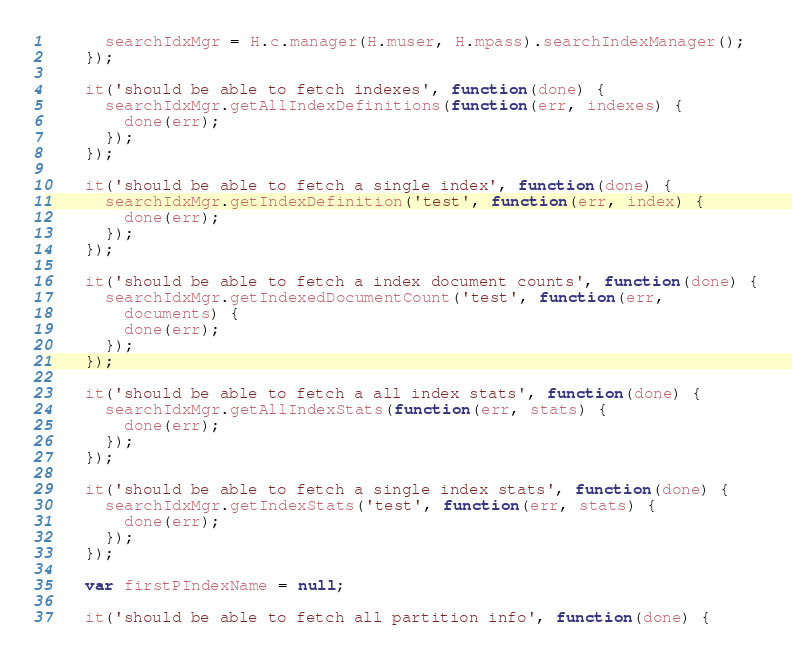<code> <loc_0><loc_0><loc_500><loc_500><_JavaScript_>      searchIdxMgr = H.c.manager(H.muser, H.mpass).searchIndexManager();
    });

    it('should be able to fetch indexes', function(done) {
      searchIdxMgr.getAllIndexDefinitions(function(err, indexes) {
        done(err);
      });
    });

    it('should be able to fetch a single index', function(done) {
      searchIdxMgr.getIndexDefinition('test', function(err, index) {
        done(err);
      });
    });

    it('should be able to fetch a index document counts', function(done) {
      searchIdxMgr.getIndexedDocumentCount('test', function(err,
        documents) {
        done(err);
      });
    });

    it('should be able to fetch a all index stats', function(done) {
      searchIdxMgr.getAllIndexStats(function(err, stats) {
        done(err);
      });
    });

    it('should be able to fetch a single index stats', function(done) {
      searchIdxMgr.getIndexStats('test', function(err, stats) {
        done(err);
      });
    });

    var firstPIndexName = null;

    it('should be able to fetch all partition info', function(done) {</code> 